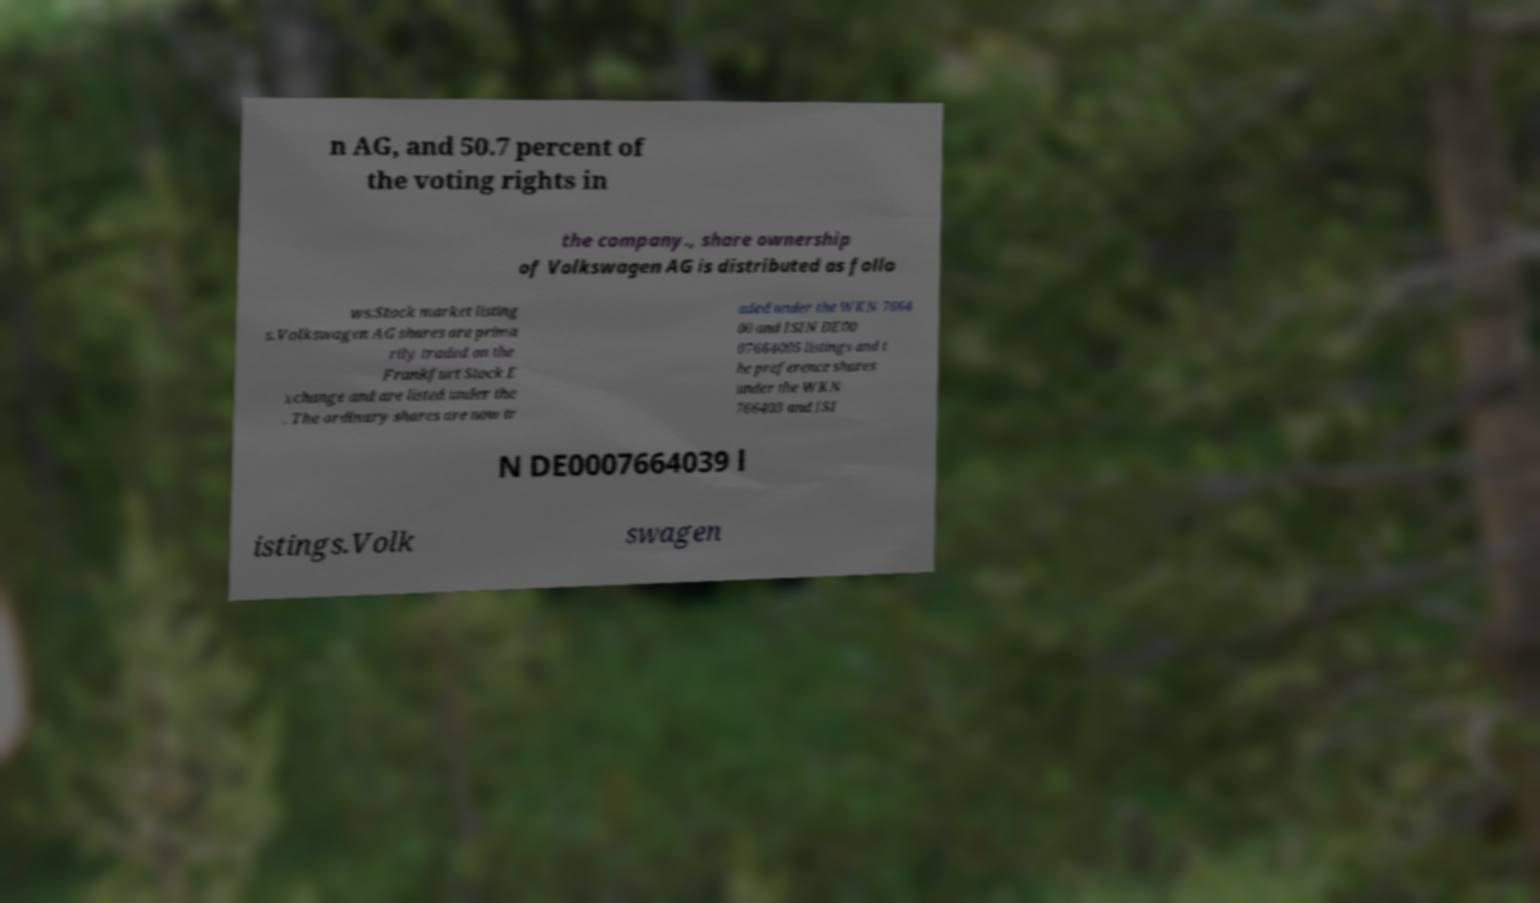Please read and relay the text visible in this image. What does it say? n AG, and 50.7 percent of the voting rights in the company., share ownership of Volkswagen AG is distributed as follo ws:Stock market listing s.Volkswagen AG shares are prima rily traded on the Frankfurt Stock E xchange and are listed under the . The ordinary shares are now tr aded under the WKN 7664 00 and ISIN DE00 07664005 listings and t he preference shares under the WKN 766403 and ISI N DE0007664039 l istings.Volk swagen 